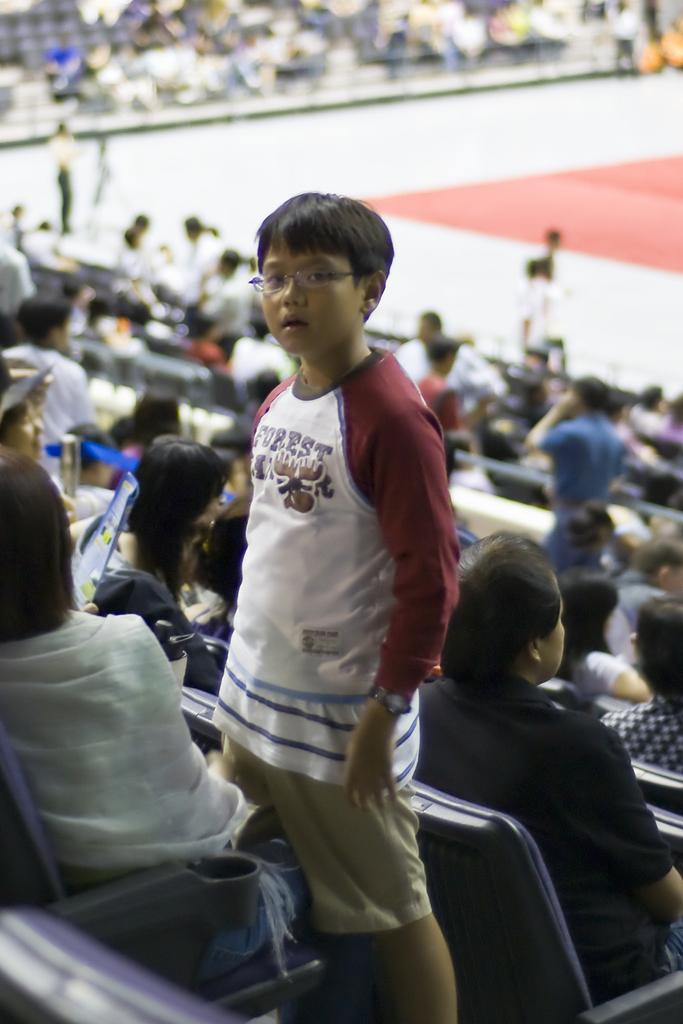What is the main subject of the image? There is a boy standing in the center of the image. What can be seen in the background of the image? There are bleachers in the image. What is the composition of the crowd in the image? There is a crowd in the image, with some people sitting and some standing. What type of plantation can be seen in the image? There is no plantation present in the image. What star is visible in the image? There is no star visible in the image. 